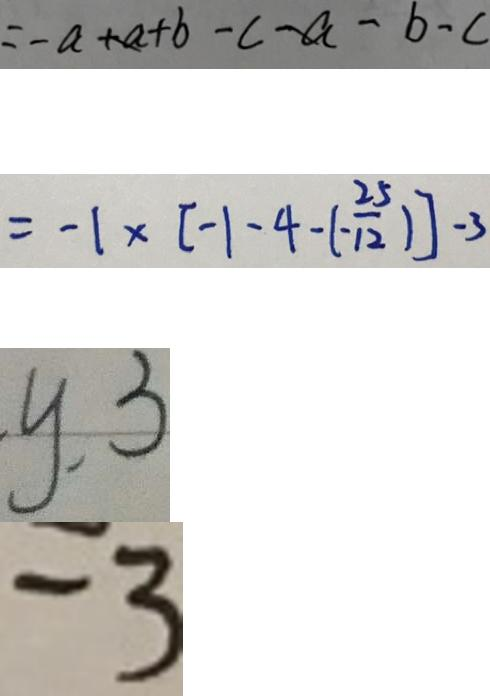<formula> <loc_0><loc_0><loc_500><loc_500>= - a + b - c - b - c 
 = - 1 \times [ - 1 - 4 - ( - \frac { 2 5 } { 1 2 } ) ] - 3 
 y . 3 
 - 3</formula> 